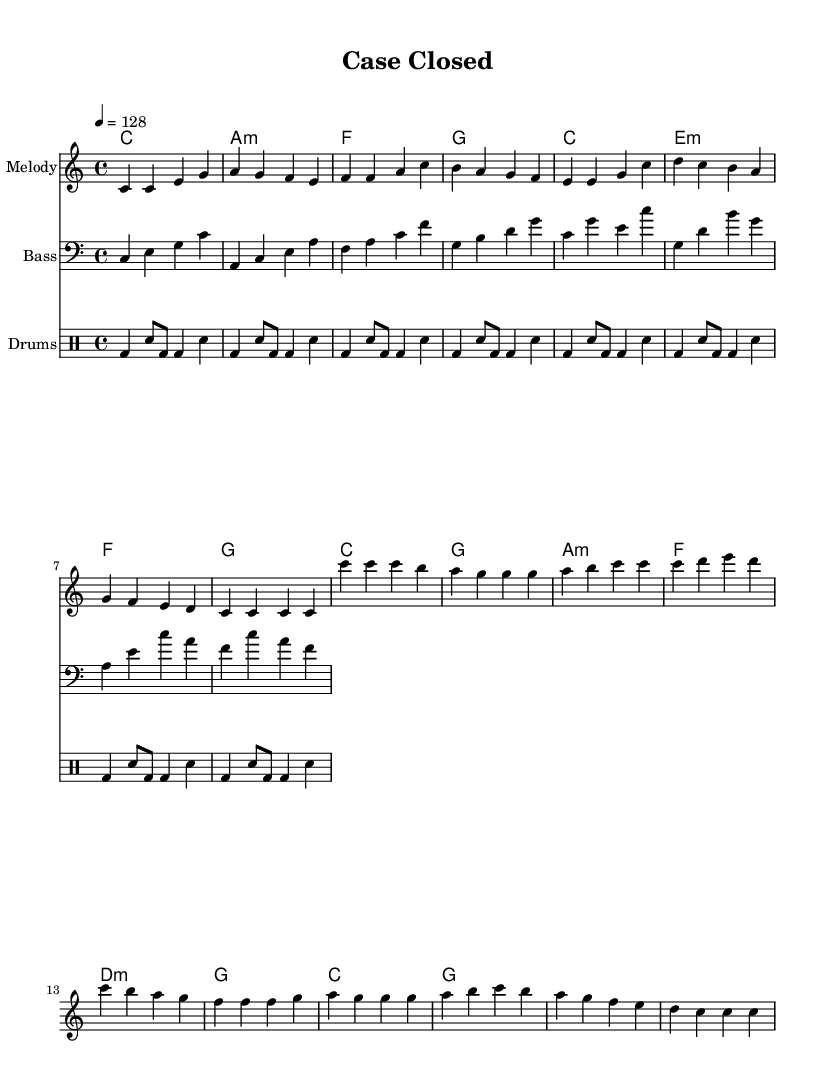What is the key signature of this music? The key signature is C major, which has no sharps or flats.
Answer: C major What is the time signature of the music? The time signature is indicated as 4/4, meaning there are four beats per measure.
Answer: 4/4 What is the tempo marking for the piece? The tempo marking is 128 beats per minute, which is a moderate tempo suitable for pop music.
Answer: 128 How many measures are in the verse section of the music? The verse consists of 8 measures, as evident from the first section of the melody before transitioning to the chorus.
Answer: 8 How many different chords are used in the chorus? The chorus features 5 different chords: C, G, A minor, F, and D minor, which create a dynamic harmonic structure.
Answer: 5 What is the specific function of the bass part in this piece? The bass part supports the harmony and provides a rhythmic foundation, enhancing the groove typical in pop music.
Answer: Supports harmony What is the predominant drum pattern used throughout the piece? The predominant drum pattern consists of a kick drum on the downbeats and snares on the upbeat, creating a driving rhythm.
Answer: Kick and snare 